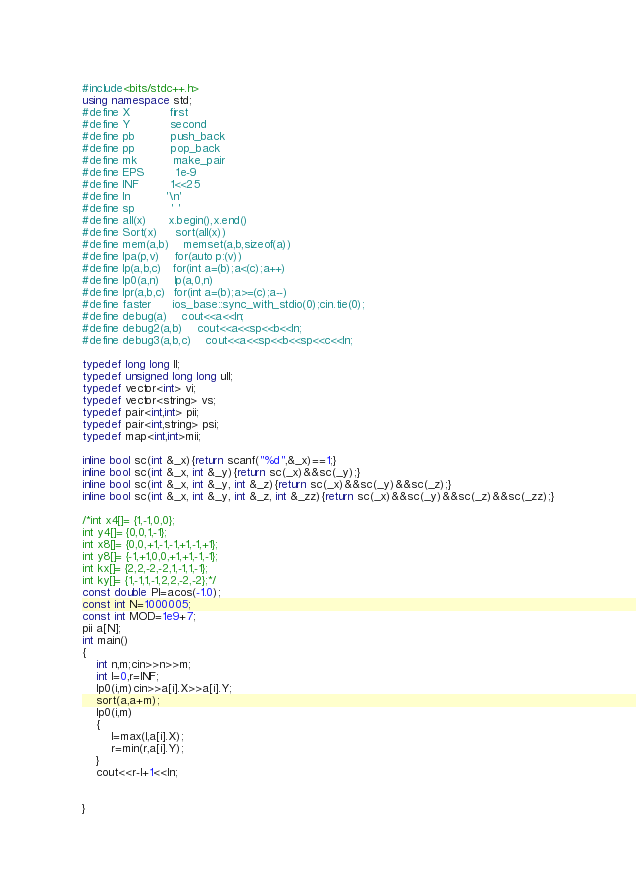Convert code to text. <code><loc_0><loc_0><loc_500><loc_500><_C++_>#include<bits/stdc++.h>
using namespace std;
#define X           first
#define Y           second
#define pb          push_back
#define pp          pop_back
#define mk          make_pair
#define EPS         1e-9
#define INF         1<<25
#define ln          '\n'
#define sp          ' '
#define all(x)      x.begin(),x.end()
#define Sort(x)     sort(all(x))
#define mem(a,b)    memset(a,b,sizeof(a))
#define lpa(p,v)    for(auto p:(v))
#define lp(a,b,c)   for(int a=(b);a<(c);a++)
#define lp0(a,n)    lp(a,0,n)
#define lpr(a,b,c)  for(int a=(b);a>=(c);a--)
#define faster      ios_base::sync_with_stdio(0);cin.tie(0);
#define debug(a)    cout<<a<<ln;
#define debug2(a,b)    cout<<a<<sp<<b<<ln;
#define debug3(a,b,c)    cout<<a<<sp<<b<<sp<<c<<ln;

typedef long long ll;
typedef unsigned long long ull;
typedef vector<int> vi;
typedef vector<string> vs;
typedef pair<int,int> pii;
typedef pair<int,string> psi;
typedef map<int,int>mii;

inline bool sc(int &_x){return scanf("%d",&_x)==1;}
inline bool sc(int &_x, int &_y){return sc(_x)&&sc(_y);}
inline bool sc(int &_x, int &_y, int &_z){return sc(_x)&&sc(_y)&&sc(_z);}
inline bool sc(int &_x, int &_y, int &_z, int &_zz){return sc(_x)&&sc(_y)&&sc(_z)&&sc(_zz);}

/*int x4[]= {1,-1,0,0};
int y4[]= {0,0,1,-1};
int x8[]= {0,0,+1,-1,-1,+1,-1,+1};
int y8[]= {-1,+1,0,0,+1,+1,-1,-1};
int kx[]= {2,2,-2,-2,1,-1,1,-1};
int ky[]= {1,-1,1,-1,2,2,-2,-2};*/
const double PI=acos(-1.0);
const int N=1000005;
const int MOD=1e9+7;
pii a[N];
int main()
{
    int n,m;cin>>n>>m;
    int l=0,r=INF;
    lp0(i,m)cin>>a[i].X>>a[i].Y;
    sort(a,a+m);
    lp0(i,m)
    {
        l=max(l,a[i].X);
        r=min(r,a[i].Y);
    }
    cout<<r-l+1<<ln;


}


</code> 